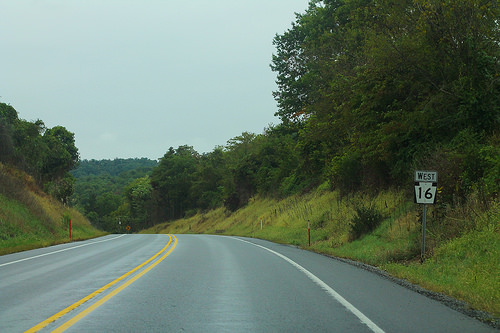<image>
Can you confirm if the road is above the sky? Yes. The road is positioned above the sky in the vertical space, higher up in the scene. 